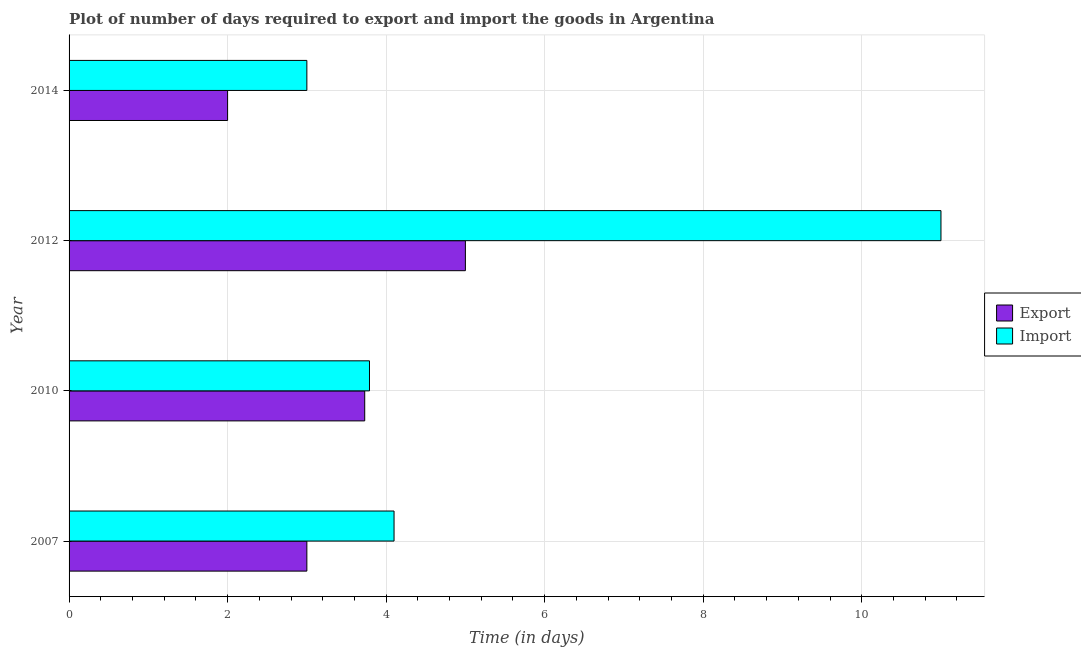How many different coloured bars are there?
Your answer should be compact. 2. Are the number of bars per tick equal to the number of legend labels?
Offer a terse response. Yes. How many bars are there on the 1st tick from the top?
Your answer should be very brief. 2. How many bars are there on the 2nd tick from the bottom?
Your answer should be very brief. 2. What is the time required to import in 2007?
Provide a succinct answer. 4.1. Across all years, what is the maximum time required to import?
Make the answer very short. 11. In which year was the time required to import maximum?
Provide a succinct answer. 2012. In which year was the time required to import minimum?
Give a very brief answer. 2014. What is the total time required to import in the graph?
Your answer should be very brief. 21.89. What is the difference between the time required to import in 2010 and that in 2014?
Your answer should be compact. 0.79. What is the difference between the time required to import in 2010 and the time required to export in 2012?
Provide a short and direct response. -1.21. What is the average time required to import per year?
Make the answer very short. 5.47. In how many years, is the time required to import greater than 0.4 days?
Offer a very short reply. 4. What is the difference between the highest and the second highest time required to export?
Give a very brief answer. 1.27. What is the difference between the highest and the lowest time required to export?
Make the answer very short. 3. Is the sum of the time required to export in 2010 and 2014 greater than the maximum time required to import across all years?
Provide a succinct answer. No. What does the 1st bar from the top in 2012 represents?
Offer a terse response. Import. What does the 2nd bar from the bottom in 2014 represents?
Offer a terse response. Import. Are all the bars in the graph horizontal?
Provide a short and direct response. Yes. How many years are there in the graph?
Offer a very short reply. 4. What is the difference between two consecutive major ticks on the X-axis?
Offer a very short reply. 2. Are the values on the major ticks of X-axis written in scientific E-notation?
Offer a terse response. No. Does the graph contain grids?
Make the answer very short. Yes. Where does the legend appear in the graph?
Keep it short and to the point. Center right. How many legend labels are there?
Your answer should be compact. 2. What is the title of the graph?
Offer a terse response. Plot of number of days required to export and import the goods in Argentina. What is the label or title of the X-axis?
Provide a short and direct response. Time (in days). What is the Time (in days) in Export in 2007?
Your response must be concise. 3. What is the Time (in days) in Import in 2007?
Keep it short and to the point. 4.1. What is the Time (in days) of Export in 2010?
Ensure brevity in your answer.  3.73. What is the Time (in days) in Import in 2010?
Give a very brief answer. 3.79. What is the Time (in days) of Import in 2012?
Provide a succinct answer. 11. What is the Time (in days) in Import in 2014?
Provide a succinct answer. 3. Across all years, what is the minimum Time (in days) in Import?
Ensure brevity in your answer.  3. What is the total Time (in days) of Export in the graph?
Give a very brief answer. 13.73. What is the total Time (in days) of Import in the graph?
Provide a succinct answer. 21.89. What is the difference between the Time (in days) of Export in 2007 and that in 2010?
Offer a terse response. -0.73. What is the difference between the Time (in days) in Import in 2007 and that in 2010?
Keep it short and to the point. 0.31. What is the difference between the Time (in days) of Export in 2007 and that in 2012?
Your answer should be very brief. -2. What is the difference between the Time (in days) in Export in 2007 and that in 2014?
Provide a succinct answer. 1. What is the difference between the Time (in days) in Export in 2010 and that in 2012?
Provide a short and direct response. -1.27. What is the difference between the Time (in days) in Import in 2010 and that in 2012?
Your response must be concise. -7.21. What is the difference between the Time (in days) of Export in 2010 and that in 2014?
Provide a succinct answer. 1.73. What is the difference between the Time (in days) in Import in 2010 and that in 2014?
Provide a short and direct response. 0.79. What is the difference between the Time (in days) of Export in 2012 and that in 2014?
Offer a very short reply. 3. What is the difference between the Time (in days) in Import in 2012 and that in 2014?
Provide a short and direct response. 8. What is the difference between the Time (in days) of Export in 2007 and the Time (in days) of Import in 2010?
Offer a very short reply. -0.79. What is the difference between the Time (in days) of Export in 2007 and the Time (in days) of Import in 2012?
Make the answer very short. -8. What is the difference between the Time (in days) of Export in 2007 and the Time (in days) of Import in 2014?
Provide a succinct answer. 0. What is the difference between the Time (in days) of Export in 2010 and the Time (in days) of Import in 2012?
Make the answer very short. -7.27. What is the difference between the Time (in days) of Export in 2010 and the Time (in days) of Import in 2014?
Your response must be concise. 0.73. What is the average Time (in days) in Export per year?
Provide a succinct answer. 3.43. What is the average Time (in days) in Import per year?
Ensure brevity in your answer.  5.47. In the year 2007, what is the difference between the Time (in days) of Export and Time (in days) of Import?
Make the answer very short. -1.1. In the year 2010, what is the difference between the Time (in days) in Export and Time (in days) in Import?
Provide a succinct answer. -0.06. In the year 2012, what is the difference between the Time (in days) in Export and Time (in days) in Import?
Offer a very short reply. -6. In the year 2014, what is the difference between the Time (in days) of Export and Time (in days) of Import?
Make the answer very short. -1. What is the ratio of the Time (in days) in Export in 2007 to that in 2010?
Ensure brevity in your answer.  0.8. What is the ratio of the Time (in days) in Import in 2007 to that in 2010?
Offer a very short reply. 1.08. What is the ratio of the Time (in days) in Import in 2007 to that in 2012?
Offer a very short reply. 0.37. What is the ratio of the Time (in days) of Export in 2007 to that in 2014?
Give a very brief answer. 1.5. What is the ratio of the Time (in days) in Import in 2007 to that in 2014?
Offer a very short reply. 1.37. What is the ratio of the Time (in days) of Export in 2010 to that in 2012?
Provide a short and direct response. 0.75. What is the ratio of the Time (in days) of Import in 2010 to that in 2012?
Keep it short and to the point. 0.34. What is the ratio of the Time (in days) in Export in 2010 to that in 2014?
Your response must be concise. 1.86. What is the ratio of the Time (in days) of Import in 2010 to that in 2014?
Your response must be concise. 1.26. What is the ratio of the Time (in days) of Import in 2012 to that in 2014?
Offer a very short reply. 3.67. What is the difference between the highest and the second highest Time (in days) in Export?
Your response must be concise. 1.27. 